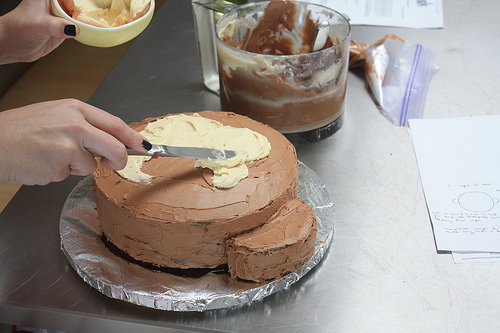<image>
Is there a knife on the cake? Yes. Looking at the image, I can see the knife is positioned on top of the cake, with the cake providing support. Is the plate under the cake? Yes. The plate is positioned underneath the cake, with the cake above it in the vertical space. Where is the cake in relation to the cup? Is it behind the cup? No. The cake is not behind the cup. From this viewpoint, the cake appears to be positioned elsewhere in the scene. Is there a chocolate cake next to the table? No. The chocolate cake is not positioned next to the table. They are located in different areas of the scene. 